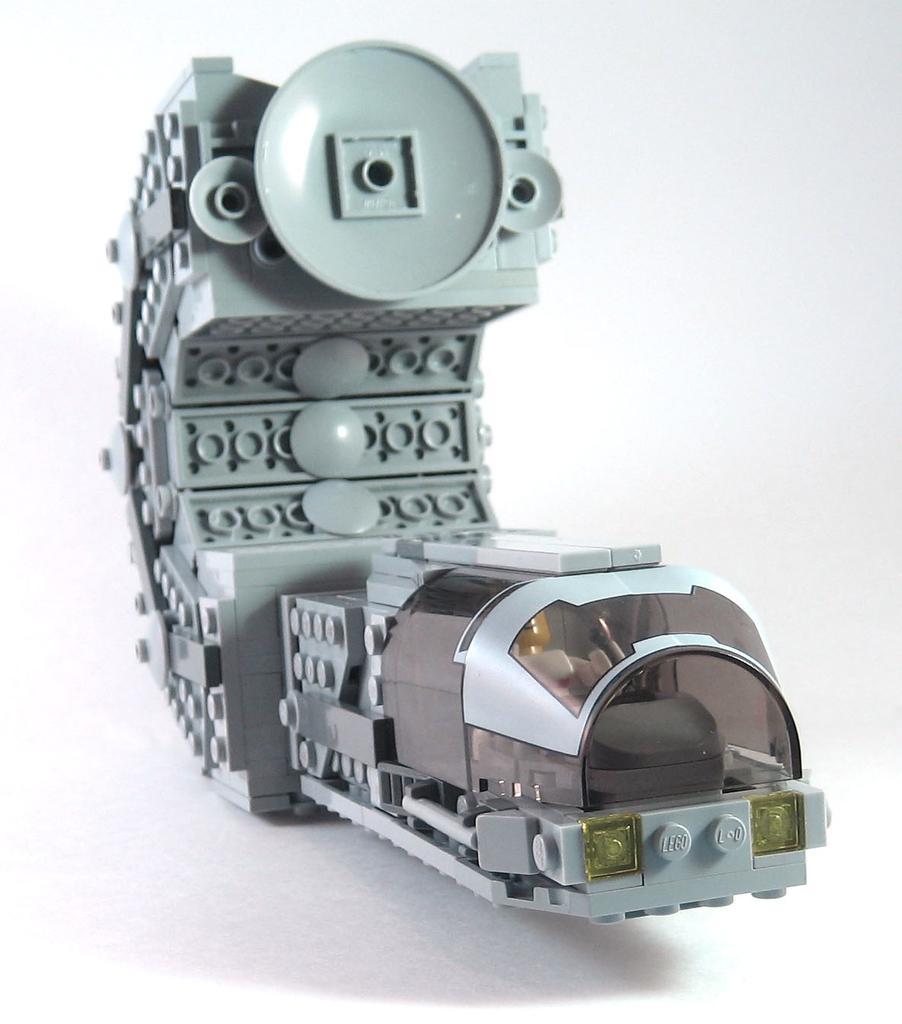In one or two sentences, can you explain what this image depicts? In this image we can see the toy with white background. 